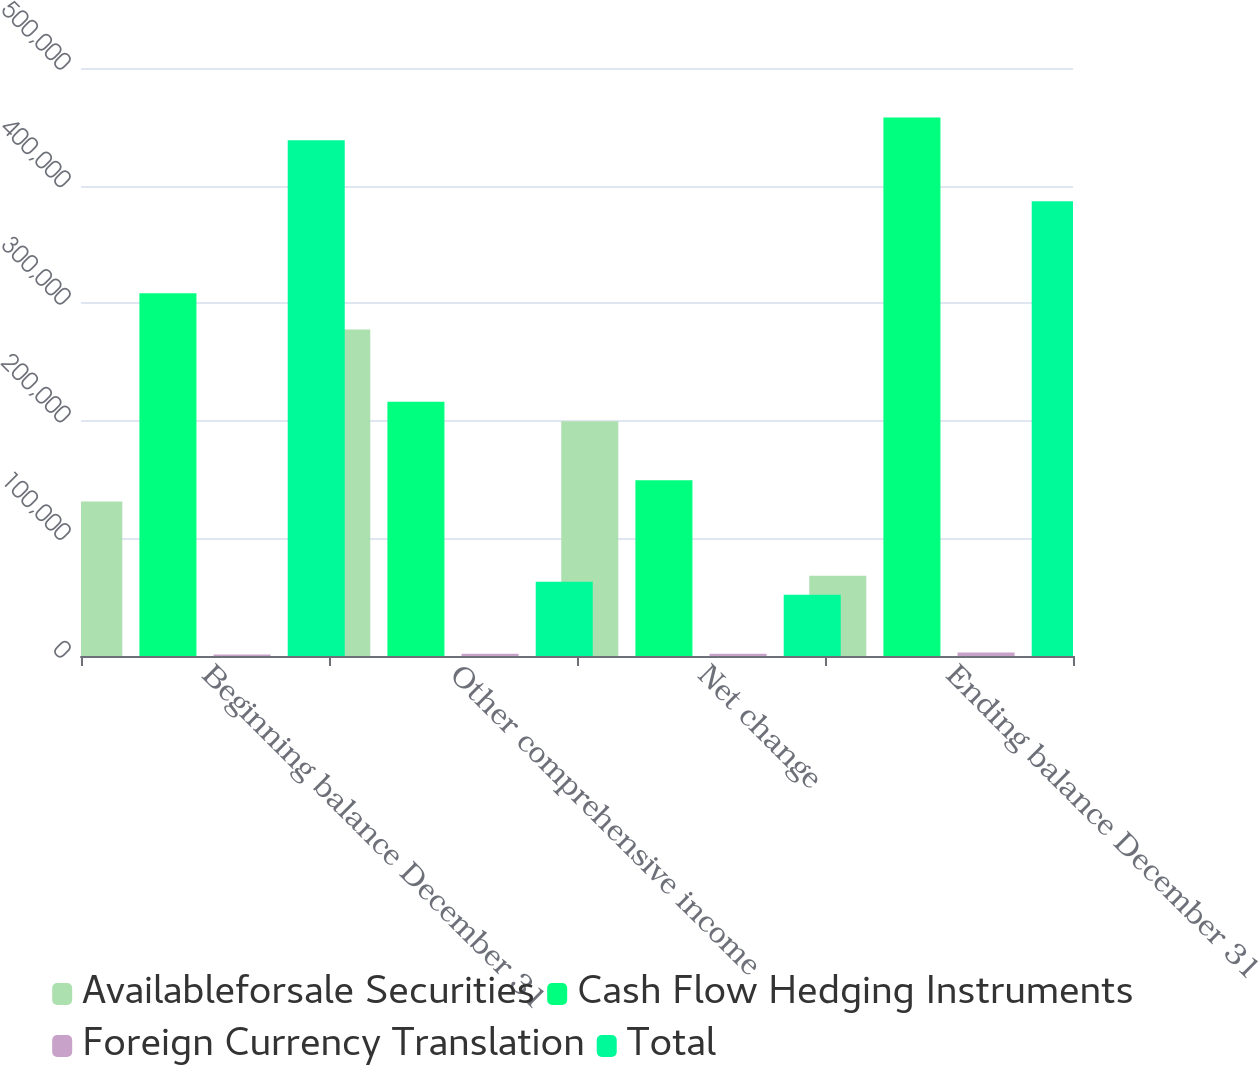Convert chart to OTSL. <chart><loc_0><loc_0><loc_500><loc_500><stacked_bar_chart><ecel><fcel>Beginning balance December 31<fcel>Other comprehensive income<fcel>Net change<fcel>Ending balance December 31<nl><fcel>Availableforsale Securities<fcel>131313<fcel>277703<fcel>199643<fcel>68330<nl><fcel>Cash Flow Hedging Instruments<fcel>308498<fcel>216302<fcel>149455<fcel>457953<nl><fcel>Foreign Currency Translation<fcel>1171<fcel>1823<fcel>1823<fcel>2994<nl><fcel>Total<fcel>438640<fcel>63224<fcel>52011<fcel>386629<nl></chart> 